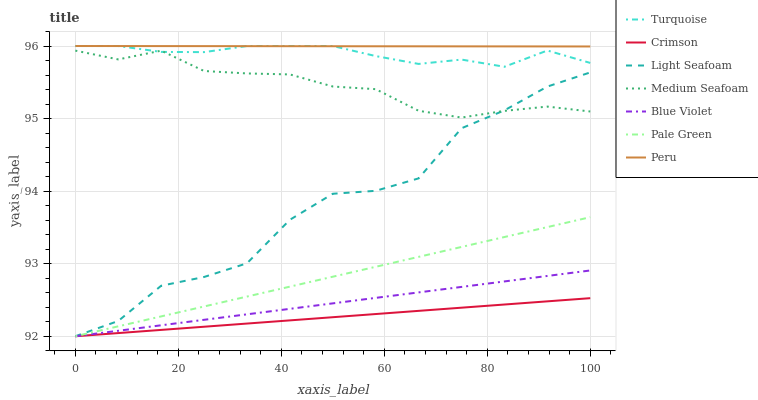Does Crimson have the minimum area under the curve?
Answer yes or no. Yes. Does Peru have the maximum area under the curve?
Answer yes or no. Yes. Does Pale Green have the minimum area under the curve?
Answer yes or no. No. Does Pale Green have the maximum area under the curve?
Answer yes or no. No. Is Crimson the smoothest?
Answer yes or no. Yes. Is Light Seafoam the roughest?
Answer yes or no. Yes. Is Pale Green the smoothest?
Answer yes or no. No. Is Pale Green the roughest?
Answer yes or no. No. Does Pale Green have the lowest value?
Answer yes or no. Yes. Does Peru have the lowest value?
Answer yes or no. No. Does Peru have the highest value?
Answer yes or no. Yes. Does Pale Green have the highest value?
Answer yes or no. No. Is Crimson less than Turquoise?
Answer yes or no. Yes. Is Medium Seafoam greater than Blue Violet?
Answer yes or no. Yes. Does Peru intersect Turquoise?
Answer yes or no. Yes. Is Peru less than Turquoise?
Answer yes or no. No. Is Peru greater than Turquoise?
Answer yes or no. No. Does Crimson intersect Turquoise?
Answer yes or no. No. 